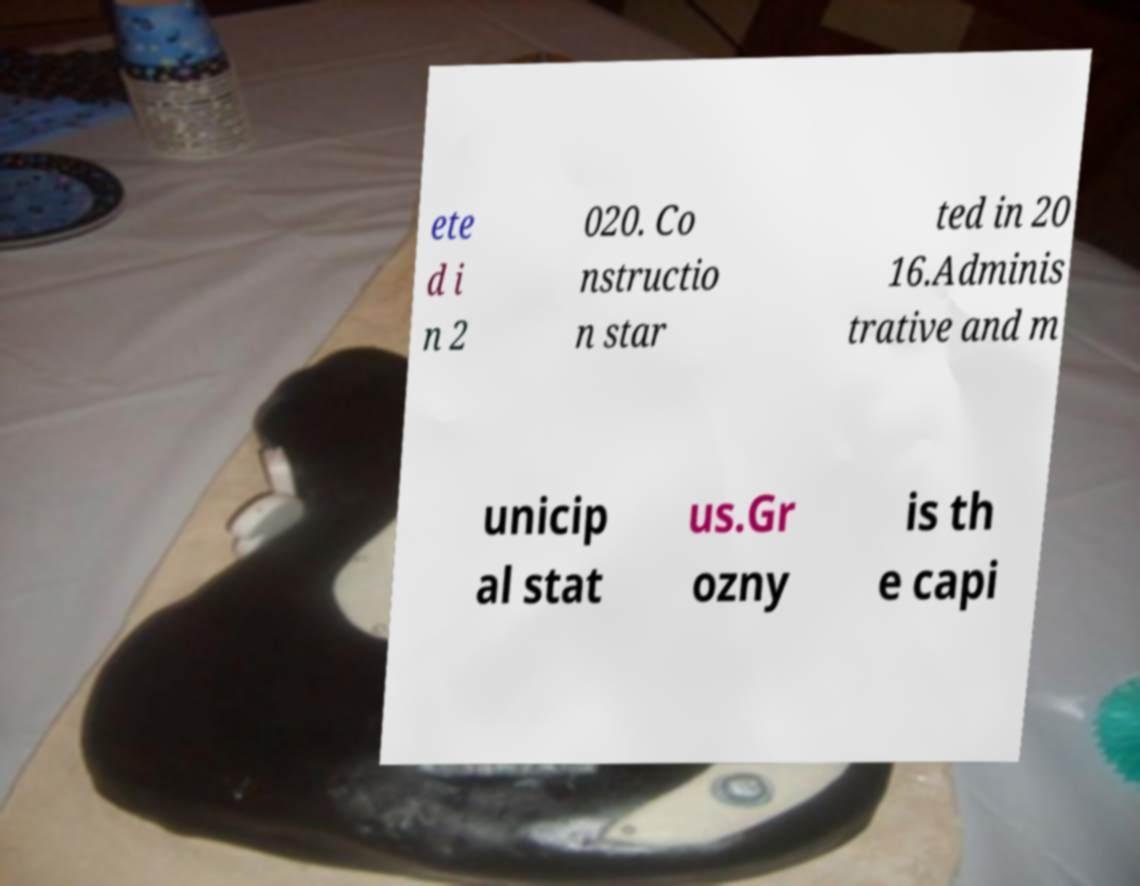Please identify and transcribe the text found in this image. ete d i n 2 020. Co nstructio n star ted in 20 16.Adminis trative and m unicip al stat us.Gr ozny is th e capi 